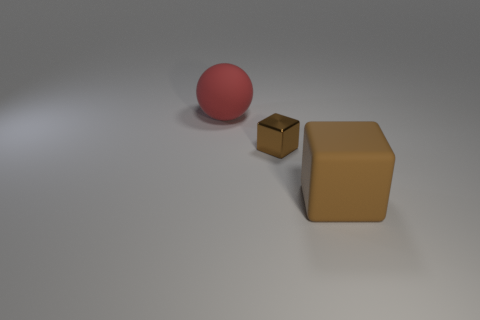Add 2 metallic spheres. How many objects exist? 5 Subtract 0 brown balls. How many objects are left? 3 Subtract all balls. How many objects are left? 2 Subtract all red rubber spheres. Subtract all red spheres. How many objects are left? 1 Add 2 big spheres. How many big spheres are left? 3 Add 3 red objects. How many red objects exist? 4 